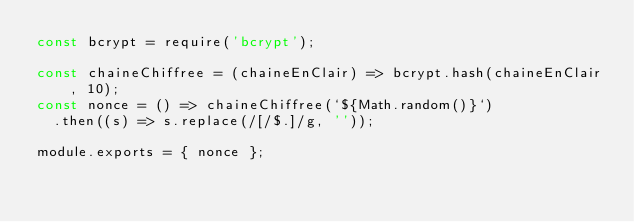<code> <loc_0><loc_0><loc_500><loc_500><_JavaScript_>const bcrypt = require('bcrypt');

const chaineChiffree = (chaineEnClair) => bcrypt.hash(chaineEnClair, 10);
const nonce = () => chaineChiffree(`${Math.random()}`)
  .then((s) => s.replace(/[/$.]/g, ''));

module.exports = { nonce };
</code> 